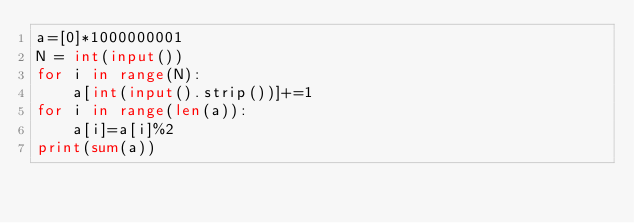<code> <loc_0><loc_0><loc_500><loc_500><_Python_>a=[0]*1000000001
N = int(input())
for i in range(N):
    a[int(input().strip())]+=1
for i in range(len(a)):
    a[i]=a[i]%2
print(sum(a))</code> 